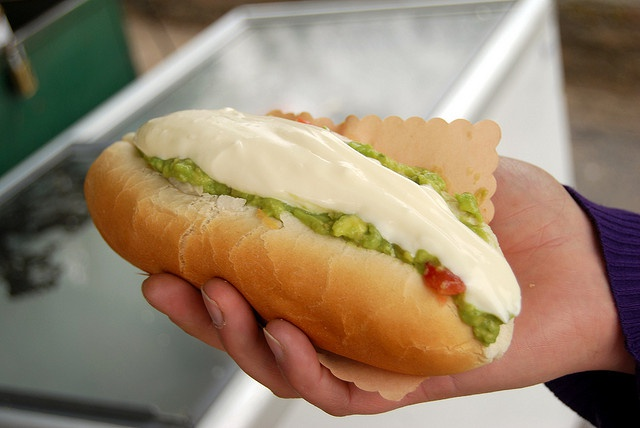Describe the objects in this image and their specific colors. I can see hot dog in black, brown, tan, and beige tones, sandwich in black, brown, tan, and beige tones, and people in black, brown, salmon, and maroon tones in this image. 